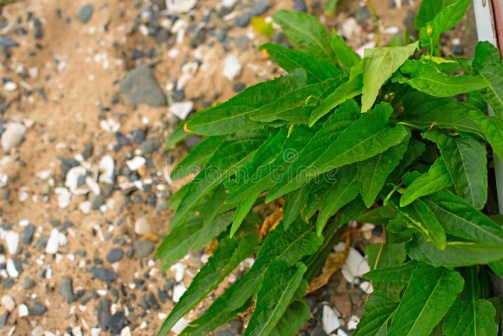Imagine the rocks and pebbles could tell a story, what would it be? If the rocks and pebbles in the image could tell a story, it would be one of endurance and transformation. Over centuries, these rocks might have been part of towering mountains, weathered down by the relentless forces of nature - wind, water, and time. Their journey would speak of resilience as they were broken down to pebbles and sand, carried by streams or rolled down slopes to settle in this current position. Each rock and pebble might hold a fragment of history, having witnessed the changing landscapes and the gradual return of life, marked by the sprouting of the tenacious plant. Together, they create a tapestry of the earth's slow, steady dance of change, highlighting the harmony and balance of natural processes. 